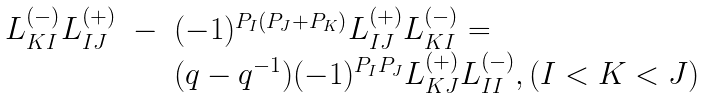<formula> <loc_0><loc_0><loc_500><loc_500>\begin{array} { l l l } L _ { K I } ^ { ( - ) } L _ { I J } ^ { ( + ) } & - & ( - 1 ) ^ { P _ { I } ( P _ { J } + P _ { K } ) } L _ { I J } ^ { ( + ) } L _ { K I } ^ { ( - ) } = \\ & & ( q - q ^ { - 1 } ) ( - 1 ) ^ { P _ { I } P _ { J } } L _ { K J } ^ { ( + ) } L _ { I I } ^ { ( - ) } , ( I < K < J ) \end{array}</formula> 